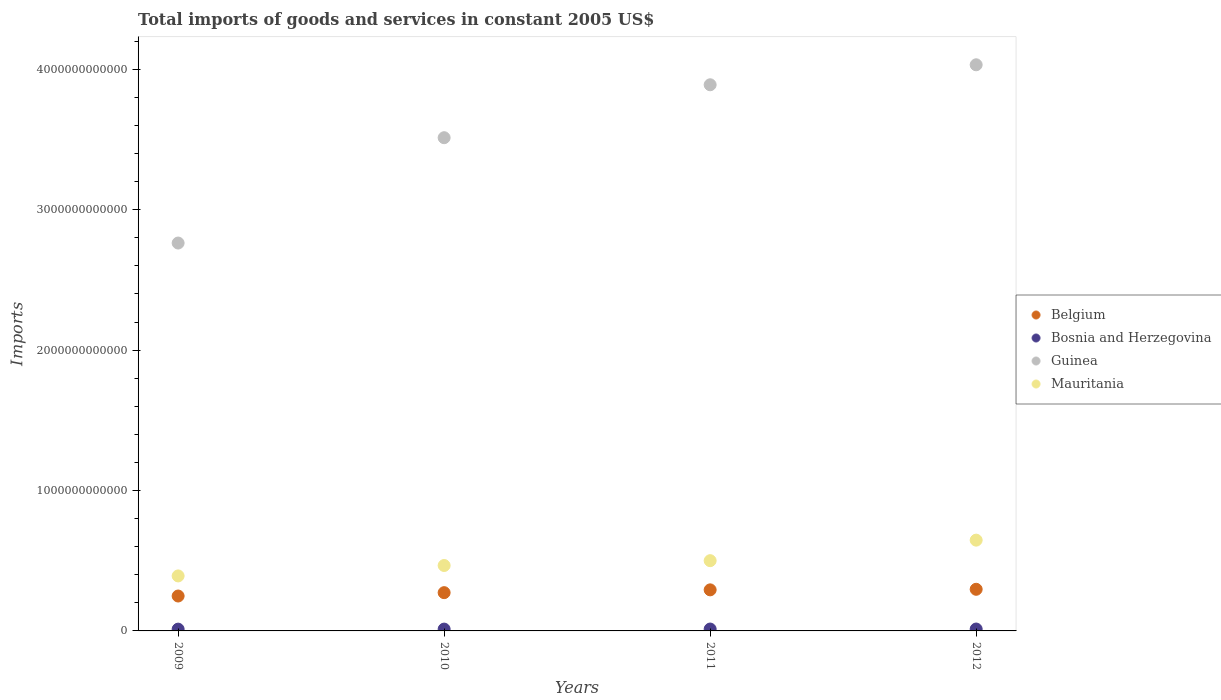Is the number of dotlines equal to the number of legend labels?
Offer a terse response. Yes. What is the total imports of goods and services in Bosnia and Herzegovina in 2009?
Offer a terse response. 1.27e+1. Across all years, what is the maximum total imports of goods and services in Mauritania?
Your answer should be very brief. 6.47e+11. Across all years, what is the minimum total imports of goods and services in Belgium?
Keep it short and to the point. 2.49e+11. In which year was the total imports of goods and services in Guinea maximum?
Provide a short and direct response. 2012. What is the total total imports of goods and services in Mauritania in the graph?
Offer a very short reply. 2.00e+12. What is the difference between the total imports of goods and services in Mauritania in 2010 and that in 2011?
Keep it short and to the point. -3.44e+1. What is the difference between the total imports of goods and services in Mauritania in 2011 and the total imports of goods and services in Guinea in 2009?
Provide a succinct answer. -2.26e+12. What is the average total imports of goods and services in Bosnia and Herzegovina per year?
Provide a succinct answer. 1.31e+1. In the year 2009, what is the difference between the total imports of goods and services in Guinea and total imports of goods and services in Belgium?
Give a very brief answer. 2.51e+12. What is the ratio of the total imports of goods and services in Mauritania in 2010 to that in 2012?
Ensure brevity in your answer.  0.72. Is the total imports of goods and services in Bosnia and Herzegovina in 2011 less than that in 2012?
Offer a terse response. Yes. Is the difference between the total imports of goods and services in Guinea in 2009 and 2011 greater than the difference between the total imports of goods and services in Belgium in 2009 and 2011?
Make the answer very short. No. What is the difference between the highest and the second highest total imports of goods and services in Bosnia and Herzegovina?
Keep it short and to the point. 8.64e+07. What is the difference between the highest and the lowest total imports of goods and services in Belgium?
Your response must be concise. 4.79e+1. Is it the case that in every year, the sum of the total imports of goods and services in Bosnia and Herzegovina and total imports of goods and services in Belgium  is greater than the total imports of goods and services in Mauritania?
Your answer should be very brief. No. Does the total imports of goods and services in Mauritania monotonically increase over the years?
Offer a very short reply. Yes. How many dotlines are there?
Offer a very short reply. 4. How many years are there in the graph?
Provide a succinct answer. 4. What is the difference between two consecutive major ticks on the Y-axis?
Make the answer very short. 1.00e+12. Are the values on the major ticks of Y-axis written in scientific E-notation?
Make the answer very short. No. Does the graph contain any zero values?
Make the answer very short. No. Does the graph contain grids?
Provide a short and direct response. No. What is the title of the graph?
Provide a succinct answer. Total imports of goods and services in constant 2005 US$. Does "Germany" appear as one of the legend labels in the graph?
Your response must be concise. No. What is the label or title of the X-axis?
Give a very brief answer. Years. What is the label or title of the Y-axis?
Provide a short and direct response. Imports. What is the Imports in Belgium in 2009?
Your answer should be very brief. 2.49e+11. What is the Imports of Bosnia and Herzegovina in 2009?
Your answer should be very brief. 1.27e+1. What is the Imports of Guinea in 2009?
Offer a very short reply. 2.76e+12. What is the Imports in Mauritania in 2009?
Offer a terse response. 3.92e+11. What is the Imports of Belgium in 2010?
Provide a succinct answer. 2.73e+11. What is the Imports in Bosnia and Herzegovina in 2010?
Keep it short and to the point. 1.30e+1. What is the Imports in Guinea in 2010?
Ensure brevity in your answer.  3.51e+12. What is the Imports in Mauritania in 2010?
Ensure brevity in your answer.  4.66e+11. What is the Imports of Belgium in 2011?
Ensure brevity in your answer.  2.92e+11. What is the Imports of Bosnia and Herzegovina in 2011?
Keep it short and to the point. 1.34e+1. What is the Imports in Guinea in 2011?
Your answer should be compact. 3.89e+12. What is the Imports in Mauritania in 2011?
Provide a short and direct response. 5.00e+11. What is the Imports of Belgium in 2012?
Offer a terse response. 2.97e+11. What is the Imports in Bosnia and Herzegovina in 2012?
Provide a short and direct response. 1.35e+1. What is the Imports of Guinea in 2012?
Your answer should be very brief. 4.03e+12. What is the Imports in Mauritania in 2012?
Provide a short and direct response. 6.47e+11. Across all years, what is the maximum Imports in Belgium?
Ensure brevity in your answer.  2.97e+11. Across all years, what is the maximum Imports of Bosnia and Herzegovina?
Give a very brief answer. 1.35e+1. Across all years, what is the maximum Imports in Guinea?
Offer a terse response. 4.03e+12. Across all years, what is the maximum Imports of Mauritania?
Keep it short and to the point. 6.47e+11. Across all years, what is the minimum Imports of Belgium?
Provide a succinct answer. 2.49e+11. Across all years, what is the minimum Imports in Bosnia and Herzegovina?
Your answer should be compact. 1.27e+1. Across all years, what is the minimum Imports of Guinea?
Keep it short and to the point. 2.76e+12. Across all years, what is the minimum Imports in Mauritania?
Give a very brief answer. 3.92e+11. What is the total Imports of Belgium in the graph?
Give a very brief answer. 1.11e+12. What is the total Imports of Bosnia and Herzegovina in the graph?
Your answer should be compact. 5.26e+1. What is the total Imports in Guinea in the graph?
Make the answer very short. 1.42e+13. What is the total Imports in Mauritania in the graph?
Give a very brief answer. 2.00e+12. What is the difference between the Imports of Belgium in 2009 and that in 2010?
Your answer should be very brief. -2.39e+1. What is the difference between the Imports in Bosnia and Herzegovina in 2009 and that in 2010?
Your response must be concise. -3.15e+08. What is the difference between the Imports in Guinea in 2009 and that in 2010?
Keep it short and to the point. -7.50e+11. What is the difference between the Imports in Mauritania in 2009 and that in 2010?
Provide a succinct answer. -7.43e+1. What is the difference between the Imports in Belgium in 2009 and that in 2011?
Make the answer very short. -4.39e+1. What is the difference between the Imports in Bosnia and Herzegovina in 2009 and that in 2011?
Keep it short and to the point. -6.94e+08. What is the difference between the Imports in Guinea in 2009 and that in 2011?
Give a very brief answer. -1.13e+12. What is the difference between the Imports of Mauritania in 2009 and that in 2011?
Make the answer very short. -1.09e+11. What is the difference between the Imports in Belgium in 2009 and that in 2012?
Your response must be concise. -4.79e+1. What is the difference between the Imports in Bosnia and Herzegovina in 2009 and that in 2012?
Your answer should be very brief. -7.80e+08. What is the difference between the Imports in Guinea in 2009 and that in 2012?
Provide a short and direct response. -1.27e+12. What is the difference between the Imports in Mauritania in 2009 and that in 2012?
Your answer should be compact. -2.55e+11. What is the difference between the Imports in Belgium in 2010 and that in 2011?
Give a very brief answer. -1.99e+1. What is the difference between the Imports in Bosnia and Herzegovina in 2010 and that in 2011?
Offer a terse response. -3.79e+08. What is the difference between the Imports in Guinea in 2010 and that in 2011?
Offer a terse response. -3.77e+11. What is the difference between the Imports of Mauritania in 2010 and that in 2011?
Offer a very short reply. -3.44e+1. What is the difference between the Imports in Belgium in 2010 and that in 2012?
Your answer should be very brief. -2.40e+1. What is the difference between the Imports in Bosnia and Herzegovina in 2010 and that in 2012?
Provide a succinct answer. -4.66e+08. What is the difference between the Imports of Guinea in 2010 and that in 2012?
Give a very brief answer. -5.19e+11. What is the difference between the Imports of Mauritania in 2010 and that in 2012?
Make the answer very short. -1.81e+11. What is the difference between the Imports in Belgium in 2011 and that in 2012?
Offer a very short reply. -4.03e+09. What is the difference between the Imports of Bosnia and Herzegovina in 2011 and that in 2012?
Provide a short and direct response. -8.64e+07. What is the difference between the Imports of Guinea in 2011 and that in 2012?
Offer a very short reply. -1.42e+11. What is the difference between the Imports of Mauritania in 2011 and that in 2012?
Your answer should be compact. -1.46e+11. What is the difference between the Imports in Belgium in 2009 and the Imports in Bosnia and Herzegovina in 2010?
Your response must be concise. 2.36e+11. What is the difference between the Imports in Belgium in 2009 and the Imports in Guinea in 2010?
Your answer should be compact. -3.26e+12. What is the difference between the Imports of Belgium in 2009 and the Imports of Mauritania in 2010?
Your answer should be compact. -2.17e+11. What is the difference between the Imports in Bosnia and Herzegovina in 2009 and the Imports in Guinea in 2010?
Make the answer very short. -3.50e+12. What is the difference between the Imports in Bosnia and Herzegovina in 2009 and the Imports in Mauritania in 2010?
Ensure brevity in your answer.  -4.53e+11. What is the difference between the Imports in Guinea in 2009 and the Imports in Mauritania in 2010?
Make the answer very short. 2.30e+12. What is the difference between the Imports in Belgium in 2009 and the Imports in Bosnia and Herzegovina in 2011?
Your answer should be compact. 2.35e+11. What is the difference between the Imports in Belgium in 2009 and the Imports in Guinea in 2011?
Offer a very short reply. -3.64e+12. What is the difference between the Imports of Belgium in 2009 and the Imports of Mauritania in 2011?
Offer a very short reply. -2.52e+11. What is the difference between the Imports of Bosnia and Herzegovina in 2009 and the Imports of Guinea in 2011?
Make the answer very short. -3.88e+12. What is the difference between the Imports of Bosnia and Herzegovina in 2009 and the Imports of Mauritania in 2011?
Offer a very short reply. -4.88e+11. What is the difference between the Imports of Guinea in 2009 and the Imports of Mauritania in 2011?
Give a very brief answer. 2.26e+12. What is the difference between the Imports in Belgium in 2009 and the Imports in Bosnia and Herzegovina in 2012?
Make the answer very short. 2.35e+11. What is the difference between the Imports of Belgium in 2009 and the Imports of Guinea in 2012?
Make the answer very short. -3.78e+12. What is the difference between the Imports of Belgium in 2009 and the Imports of Mauritania in 2012?
Give a very brief answer. -3.98e+11. What is the difference between the Imports of Bosnia and Herzegovina in 2009 and the Imports of Guinea in 2012?
Keep it short and to the point. -4.02e+12. What is the difference between the Imports of Bosnia and Herzegovina in 2009 and the Imports of Mauritania in 2012?
Your answer should be very brief. -6.34e+11. What is the difference between the Imports of Guinea in 2009 and the Imports of Mauritania in 2012?
Keep it short and to the point. 2.12e+12. What is the difference between the Imports of Belgium in 2010 and the Imports of Bosnia and Herzegovina in 2011?
Ensure brevity in your answer.  2.59e+11. What is the difference between the Imports in Belgium in 2010 and the Imports in Guinea in 2011?
Your answer should be very brief. -3.62e+12. What is the difference between the Imports of Belgium in 2010 and the Imports of Mauritania in 2011?
Your response must be concise. -2.28e+11. What is the difference between the Imports in Bosnia and Herzegovina in 2010 and the Imports in Guinea in 2011?
Provide a succinct answer. -3.88e+12. What is the difference between the Imports of Bosnia and Herzegovina in 2010 and the Imports of Mauritania in 2011?
Your response must be concise. -4.87e+11. What is the difference between the Imports of Guinea in 2010 and the Imports of Mauritania in 2011?
Your answer should be compact. 3.01e+12. What is the difference between the Imports of Belgium in 2010 and the Imports of Bosnia and Herzegovina in 2012?
Offer a terse response. 2.59e+11. What is the difference between the Imports in Belgium in 2010 and the Imports in Guinea in 2012?
Provide a succinct answer. -3.76e+12. What is the difference between the Imports in Belgium in 2010 and the Imports in Mauritania in 2012?
Provide a short and direct response. -3.74e+11. What is the difference between the Imports in Bosnia and Herzegovina in 2010 and the Imports in Guinea in 2012?
Provide a succinct answer. -4.02e+12. What is the difference between the Imports in Bosnia and Herzegovina in 2010 and the Imports in Mauritania in 2012?
Give a very brief answer. -6.34e+11. What is the difference between the Imports in Guinea in 2010 and the Imports in Mauritania in 2012?
Your answer should be compact. 2.87e+12. What is the difference between the Imports of Belgium in 2011 and the Imports of Bosnia and Herzegovina in 2012?
Your answer should be very brief. 2.79e+11. What is the difference between the Imports of Belgium in 2011 and the Imports of Guinea in 2012?
Ensure brevity in your answer.  -3.74e+12. What is the difference between the Imports in Belgium in 2011 and the Imports in Mauritania in 2012?
Make the answer very short. -3.54e+11. What is the difference between the Imports in Bosnia and Herzegovina in 2011 and the Imports in Guinea in 2012?
Provide a short and direct response. -4.02e+12. What is the difference between the Imports in Bosnia and Herzegovina in 2011 and the Imports in Mauritania in 2012?
Make the answer very short. -6.33e+11. What is the difference between the Imports in Guinea in 2011 and the Imports in Mauritania in 2012?
Keep it short and to the point. 3.24e+12. What is the average Imports of Belgium per year?
Ensure brevity in your answer.  2.78e+11. What is the average Imports of Bosnia and Herzegovina per year?
Give a very brief answer. 1.31e+1. What is the average Imports of Guinea per year?
Your answer should be very brief. 3.55e+12. What is the average Imports in Mauritania per year?
Offer a terse response. 5.01e+11. In the year 2009, what is the difference between the Imports in Belgium and Imports in Bosnia and Herzegovina?
Offer a very short reply. 2.36e+11. In the year 2009, what is the difference between the Imports of Belgium and Imports of Guinea?
Make the answer very short. -2.51e+12. In the year 2009, what is the difference between the Imports in Belgium and Imports in Mauritania?
Provide a short and direct response. -1.43e+11. In the year 2009, what is the difference between the Imports of Bosnia and Herzegovina and Imports of Guinea?
Give a very brief answer. -2.75e+12. In the year 2009, what is the difference between the Imports in Bosnia and Herzegovina and Imports in Mauritania?
Make the answer very short. -3.79e+11. In the year 2009, what is the difference between the Imports in Guinea and Imports in Mauritania?
Offer a terse response. 2.37e+12. In the year 2010, what is the difference between the Imports of Belgium and Imports of Bosnia and Herzegovina?
Keep it short and to the point. 2.60e+11. In the year 2010, what is the difference between the Imports of Belgium and Imports of Guinea?
Offer a terse response. -3.24e+12. In the year 2010, what is the difference between the Imports in Belgium and Imports in Mauritania?
Your response must be concise. -1.93e+11. In the year 2010, what is the difference between the Imports of Bosnia and Herzegovina and Imports of Guinea?
Offer a very short reply. -3.50e+12. In the year 2010, what is the difference between the Imports in Bosnia and Herzegovina and Imports in Mauritania?
Your answer should be compact. -4.53e+11. In the year 2010, what is the difference between the Imports in Guinea and Imports in Mauritania?
Offer a very short reply. 3.05e+12. In the year 2011, what is the difference between the Imports in Belgium and Imports in Bosnia and Herzegovina?
Your answer should be compact. 2.79e+11. In the year 2011, what is the difference between the Imports of Belgium and Imports of Guinea?
Offer a terse response. -3.60e+12. In the year 2011, what is the difference between the Imports of Belgium and Imports of Mauritania?
Ensure brevity in your answer.  -2.08e+11. In the year 2011, what is the difference between the Imports in Bosnia and Herzegovina and Imports in Guinea?
Offer a very short reply. -3.88e+12. In the year 2011, what is the difference between the Imports of Bosnia and Herzegovina and Imports of Mauritania?
Provide a short and direct response. -4.87e+11. In the year 2011, what is the difference between the Imports in Guinea and Imports in Mauritania?
Ensure brevity in your answer.  3.39e+12. In the year 2012, what is the difference between the Imports in Belgium and Imports in Bosnia and Herzegovina?
Ensure brevity in your answer.  2.83e+11. In the year 2012, what is the difference between the Imports in Belgium and Imports in Guinea?
Your answer should be compact. -3.74e+12. In the year 2012, what is the difference between the Imports in Belgium and Imports in Mauritania?
Make the answer very short. -3.50e+11. In the year 2012, what is the difference between the Imports of Bosnia and Herzegovina and Imports of Guinea?
Make the answer very short. -4.02e+12. In the year 2012, what is the difference between the Imports in Bosnia and Herzegovina and Imports in Mauritania?
Make the answer very short. -6.33e+11. In the year 2012, what is the difference between the Imports of Guinea and Imports of Mauritania?
Provide a short and direct response. 3.39e+12. What is the ratio of the Imports in Belgium in 2009 to that in 2010?
Keep it short and to the point. 0.91. What is the ratio of the Imports in Bosnia and Herzegovina in 2009 to that in 2010?
Provide a short and direct response. 0.98. What is the ratio of the Imports of Guinea in 2009 to that in 2010?
Provide a succinct answer. 0.79. What is the ratio of the Imports of Mauritania in 2009 to that in 2010?
Your answer should be compact. 0.84. What is the ratio of the Imports of Belgium in 2009 to that in 2011?
Your answer should be very brief. 0.85. What is the ratio of the Imports in Bosnia and Herzegovina in 2009 to that in 2011?
Offer a terse response. 0.95. What is the ratio of the Imports of Guinea in 2009 to that in 2011?
Make the answer very short. 0.71. What is the ratio of the Imports in Mauritania in 2009 to that in 2011?
Give a very brief answer. 0.78. What is the ratio of the Imports of Belgium in 2009 to that in 2012?
Provide a succinct answer. 0.84. What is the ratio of the Imports in Bosnia and Herzegovina in 2009 to that in 2012?
Offer a very short reply. 0.94. What is the ratio of the Imports of Guinea in 2009 to that in 2012?
Make the answer very short. 0.69. What is the ratio of the Imports in Mauritania in 2009 to that in 2012?
Your response must be concise. 0.61. What is the ratio of the Imports in Belgium in 2010 to that in 2011?
Make the answer very short. 0.93. What is the ratio of the Imports in Bosnia and Herzegovina in 2010 to that in 2011?
Offer a terse response. 0.97. What is the ratio of the Imports of Guinea in 2010 to that in 2011?
Your response must be concise. 0.9. What is the ratio of the Imports in Mauritania in 2010 to that in 2011?
Make the answer very short. 0.93. What is the ratio of the Imports of Belgium in 2010 to that in 2012?
Your answer should be compact. 0.92. What is the ratio of the Imports in Bosnia and Herzegovina in 2010 to that in 2012?
Your response must be concise. 0.97. What is the ratio of the Imports of Guinea in 2010 to that in 2012?
Keep it short and to the point. 0.87. What is the ratio of the Imports in Mauritania in 2010 to that in 2012?
Make the answer very short. 0.72. What is the ratio of the Imports of Belgium in 2011 to that in 2012?
Give a very brief answer. 0.99. What is the ratio of the Imports of Guinea in 2011 to that in 2012?
Keep it short and to the point. 0.96. What is the ratio of the Imports of Mauritania in 2011 to that in 2012?
Offer a terse response. 0.77. What is the difference between the highest and the second highest Imports in Belgium?
Your answer should be very brief. 4.03e+09. What is the difference between the highest and the second highest Imports of Bosnia and Herzegovina?
Keep it short and to the point. 8.64e+07. What is the difference between the highest and the second highest Imports in Guinea?
Your answer should be compact. 1.42e+11. What is the difference between the highest and the second highest Imports of Mauritania?
Your response must be concise. 1.46e+11. What is the difference between the highest and the lowest Imports of Belgium?
Ensure brevity in your answer.  4.79e+1. What is the difference between the highest and the lowest Imports of Bosnia and Herzegovina?
Make the answer very short. 7.80e+08. What is the difference between the highest and the lowest Imports in Guinea?
Make the answer very short. 1.27e+12. What is the difference between the highest and the lowest Imports of Mauritania?
Provide a succinct answer. 2.55e+11. 